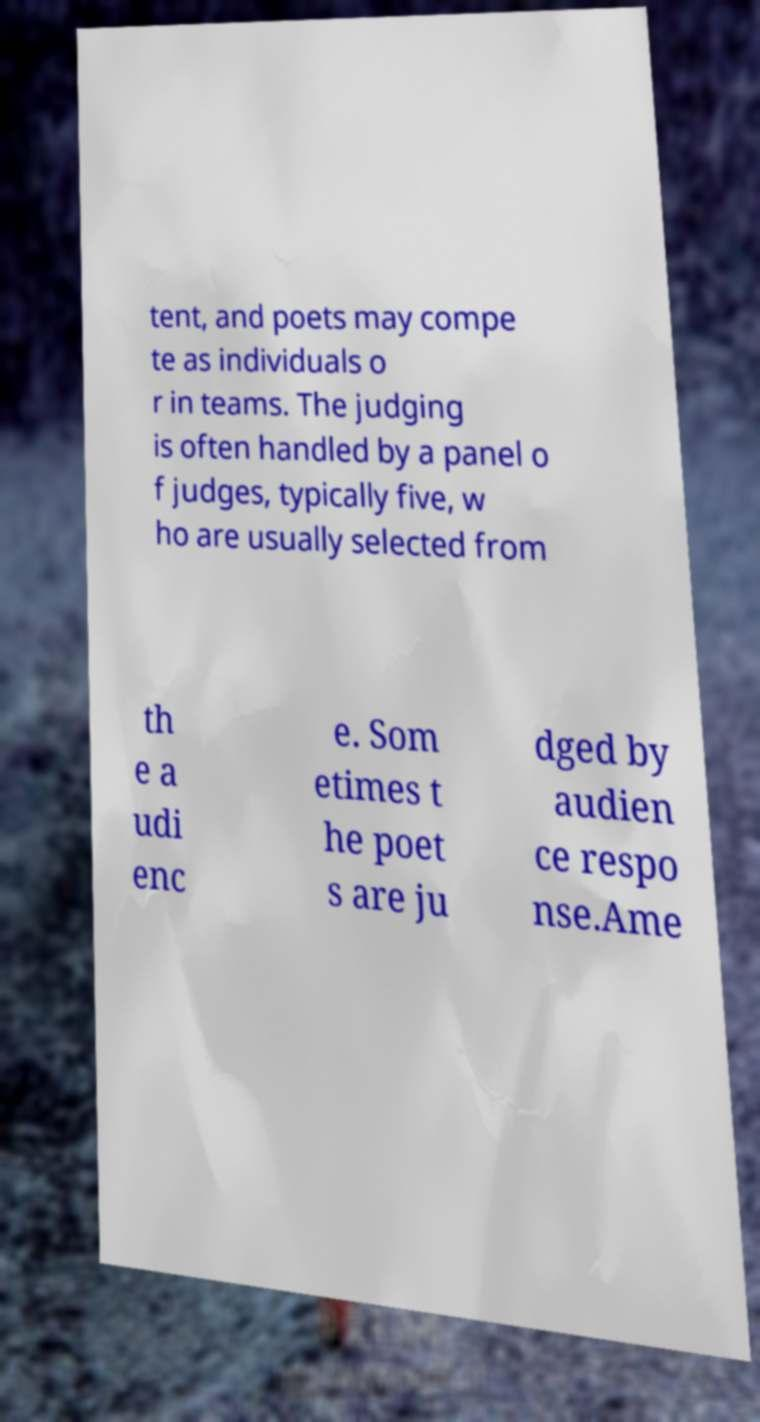Please read and relay the text visible in this image. What does it say? tent, and poets may compe te as individuals o r in teams. The judging is often handled by a panel o f judges, typically five, w ho are usually selected from th e a udi enc e. Som etimes t he poet s are ju dged by audien ce respo nse.Ame 